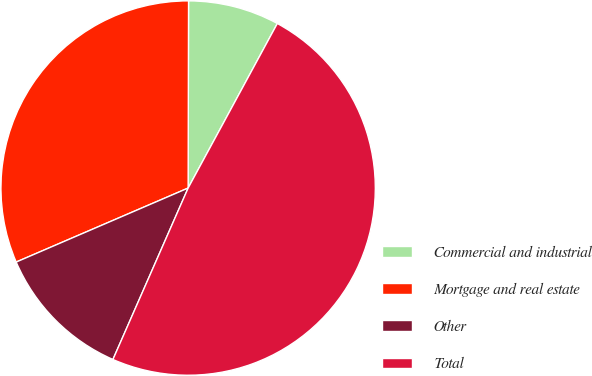Convert chart to OTSL. <chart><loc_0><loc_0><loc_500><loc_500><pie_chart><fcel>Commercial and industrial<fcel>Mortgage and real estate<fcel>Other<fcel>Total<nl><fcel>7.87%<fcel>31.5%<fcel>11.95%<fcel>48.67%<nl></chart> 